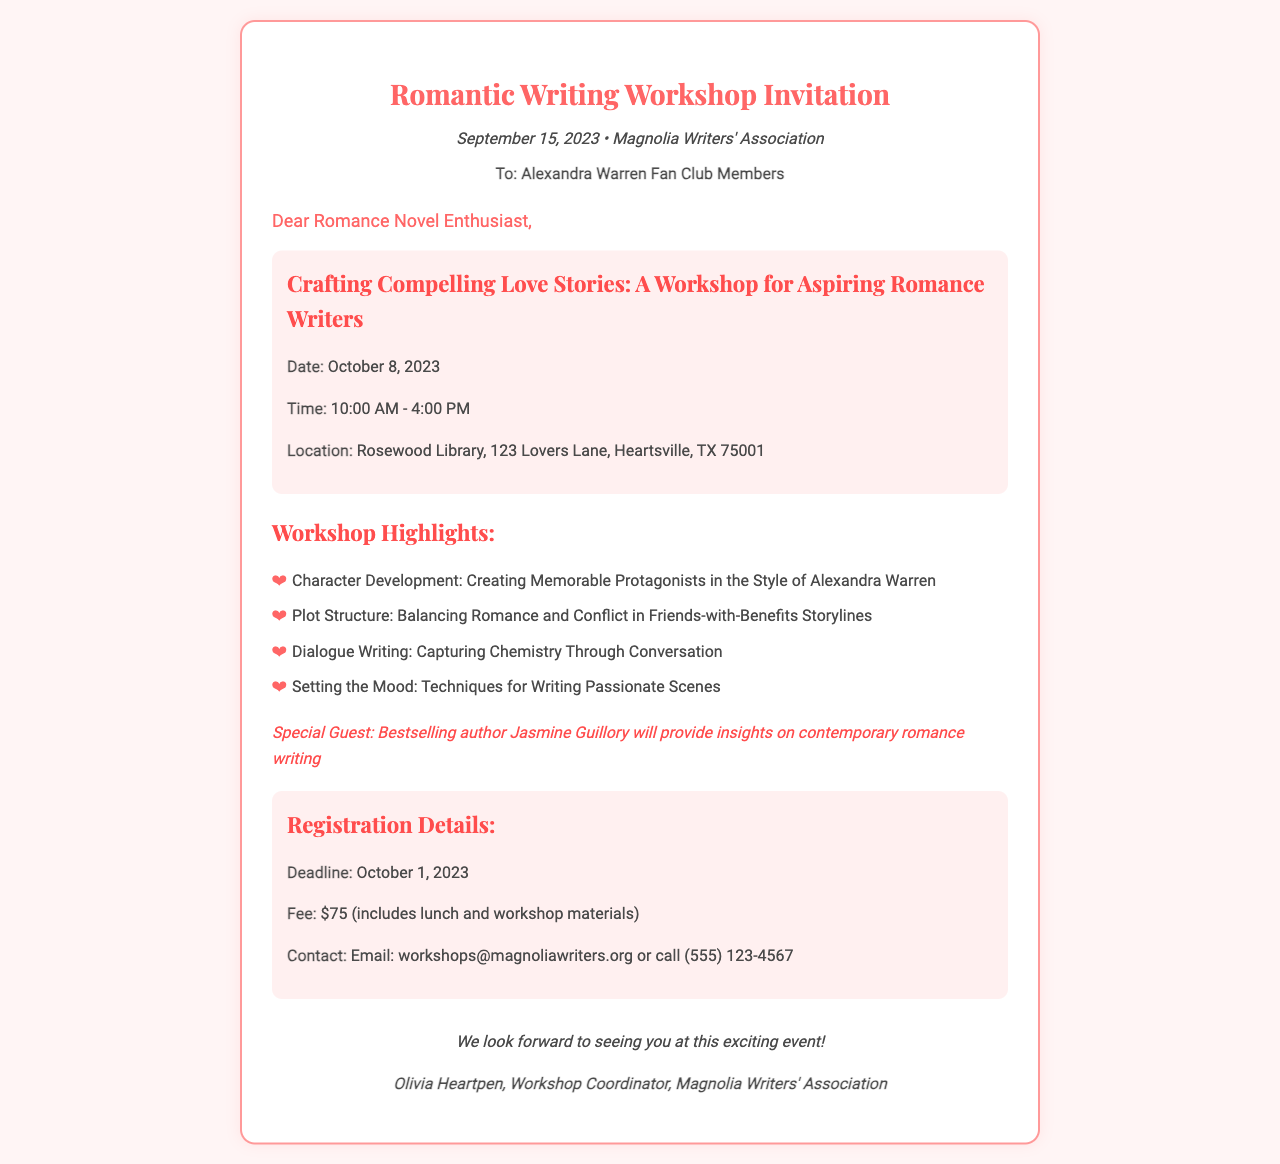what is the date of the workshop? The workshop is scheduled to take place on October 8, 2023.
Answer: October 8, 2023 who is the special guest author? The document mentions Jasmine Guillory as the special guest.
Answer: Jasmine Guillory what is the registration fee? The fee for the workshop is specified in the document as $75.
Answer: $75 where is the workshop located? The location provided in the document for the workshop is Rosewood Library, 123 Lovers Lane, Heartsville, TX 75001.
Answer: Rosewood Library, 123 Lovers Lane, Heartsville, TX 75001 what time does the workshop start? According to the document, the workshop starts at 10:00 AM.
Answer: 10:00 AM how long is the workshop scheduled to run? The document states that the workshop runs from 10:00 AM to 4:00 PM, indicating it runs for 6 hours.
Answer: 6 hours what is the deadline for registration? The document specifies that the registration deadline is October 1, 2023.
Answer: October 1, 2023 which organization is hosting the workshop? The fax indicates that the Magnolia Writers' Association is hosting the workshop.
Answer: Magnolia Writers' Association what topics will be covered in the workshop? The document lists topics such as character development, plot structure, and dialogue writing among others.
Answer: Character Development, Plot Structure, Dialogue Writing, Setting the Mood 